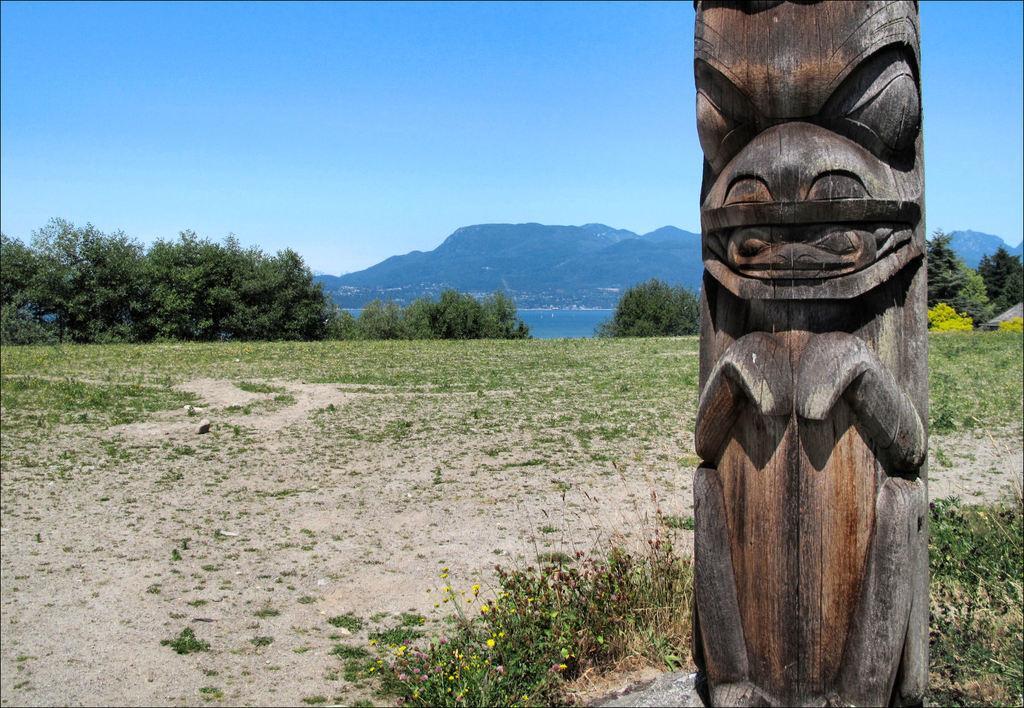Can you describe this image briefly? In this image there is a wooden structure, behind that there is a grass. In the background there are trees, river, mountains and the sky. 